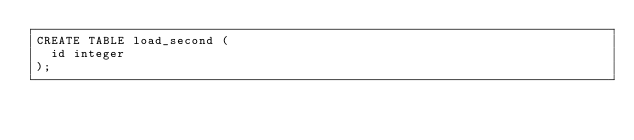<code> <loc_0><loc_0><loc_500><loc_500><_SQL_>CREATE TABLE load_second (
  id integer
);
</code> 